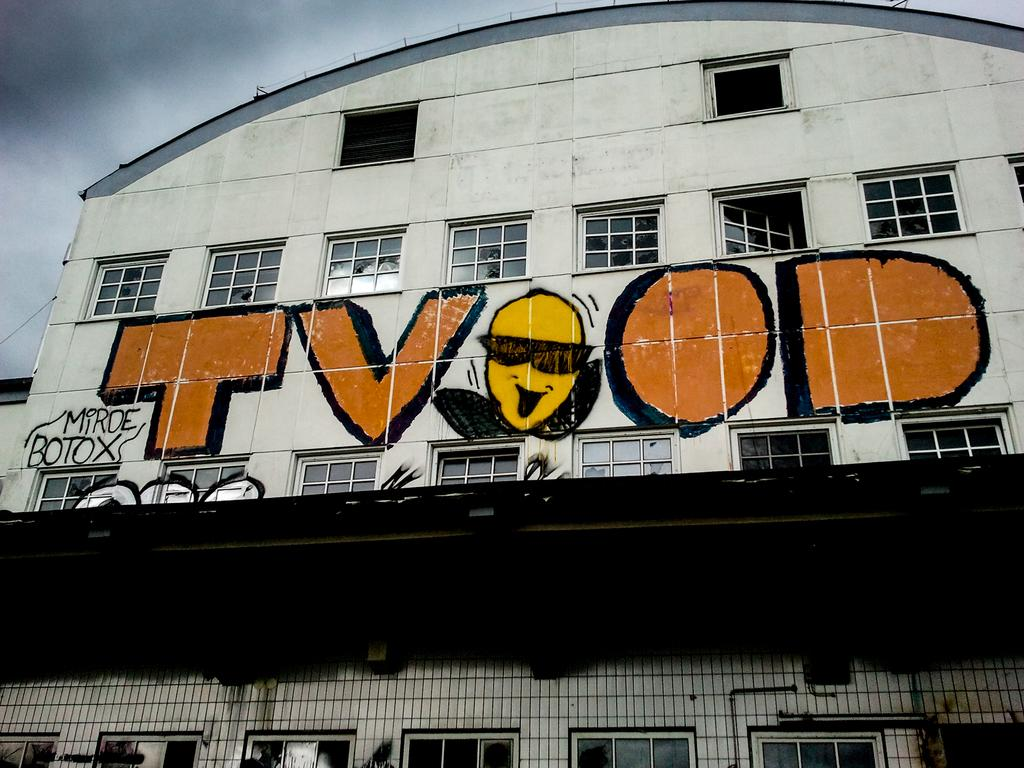What is the main subject in the foreground of the image? There is a building in the foreground of the image. What features can be observed on the building? The building has windows and a painting. What is visible at the top of the image? The sky is visible at the top of the image. Can you tell me how many umbrellas are hanging from the painting in the image? There are no umbrellas present in the image, and therefore no such objects can be observed hanging from the painting. What type of books can be seen in the library depicted in the image? There is no library depicted in the image; it features a building with windows and a painting. 